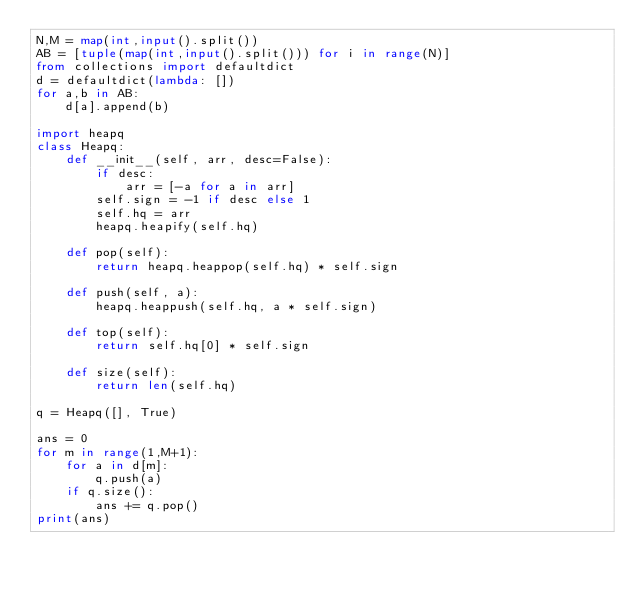<code> <loc_0><loc_0><loc_500><loc_500><_Python_>N,M = map(int,input().split())
AB = [tuple(map(int,input().split())) for i in range(N)]
from collections import defaultdict
d = defaultdict(lambda: [])
for a,b in AB:
    d[a].append(b)

import heapq
class Heapq:
    def __init__(self, arr, desc=False):
        if desc:
            arr = [-a for a in arr]
        self.sign = -1 if desc else 1
        self.hq = arr
        heapq.heapify(self.hq)

    def pop(self):
        return heapq.heappop(self.hq) * self.sign

    def push(self, a):
        heapq.heappush(self.hq, a * self.sign)

    def top(self):
        return self.hq[0] * self.sign

    def size(self):
        return len(self.hq)

q = Heapq([], True)

ans = 0
for m in range(1,M+1):
    for a in d[m]:
        q.push(a)
    if q.size():
        ans += q.pop()
print(ans)</code> 